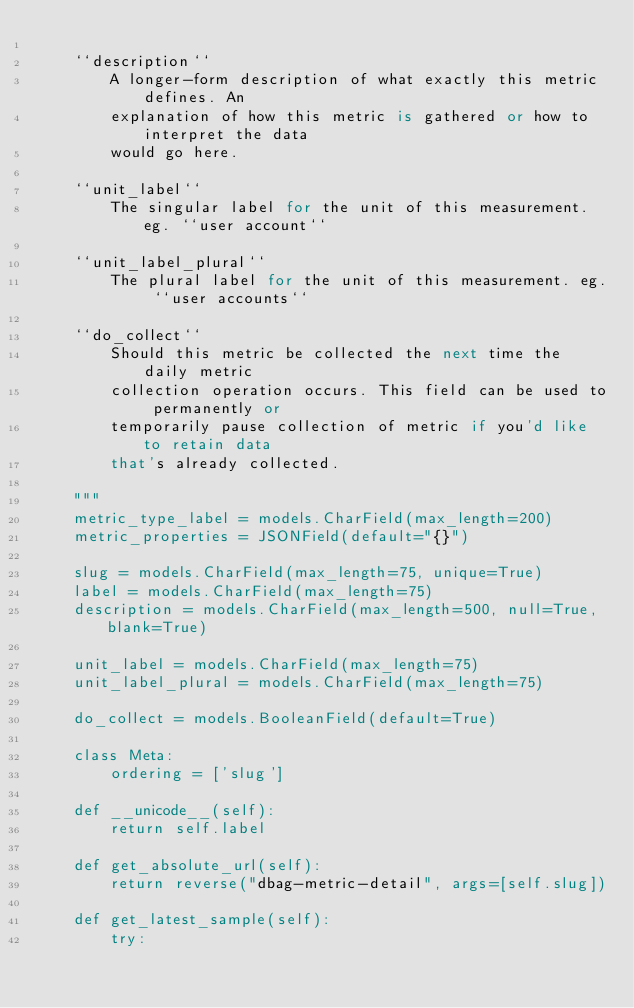Convert code to text. <code><loc_0><loc_0><loc_500><loc_500><_Python_>
    ``description``
        A longer-form description of what exactly this metric defines. An
        explanation of how this metric is gathered or how to interpret the data
        would go here.

    ``unit_label``
        The singular label for the unit of this measurement. eg. ``user account``

    ``unit_label_plural``
        The plural label for the unit of this measurement. eg. ``user accounts``

    ``do_collect``
        Should this metric be collected the next time the daily metric
        collection operation occurs. This field can be used to permanently or
        temporarily pause collection of metric if you'd like to retain data
        that's already collected.

    """
    metric_type_label = models.CharField(max_length=200)
    metric_properties = JSONField(default="{}")

    slug = models.CharField(max_length=75, unique=True)
    label = models.CharField(max_length=75)
    description = models.CharField(max_length=500, null=True, blank=True)

    unit_label = models.CharField(max_length=75)
    unit_label_plural = models.CharField(max_length=75)

    do_collect = models.BooleanField(default=True)

    class Meta:
        ordering = ['slug']

    def __unicode__(self):
        return self.label

    def get_absolute_url(self):
        return reverse("dbag-metric-detail", args=[self.slug])

    def get_latest_sample(self):
        try:</code> 